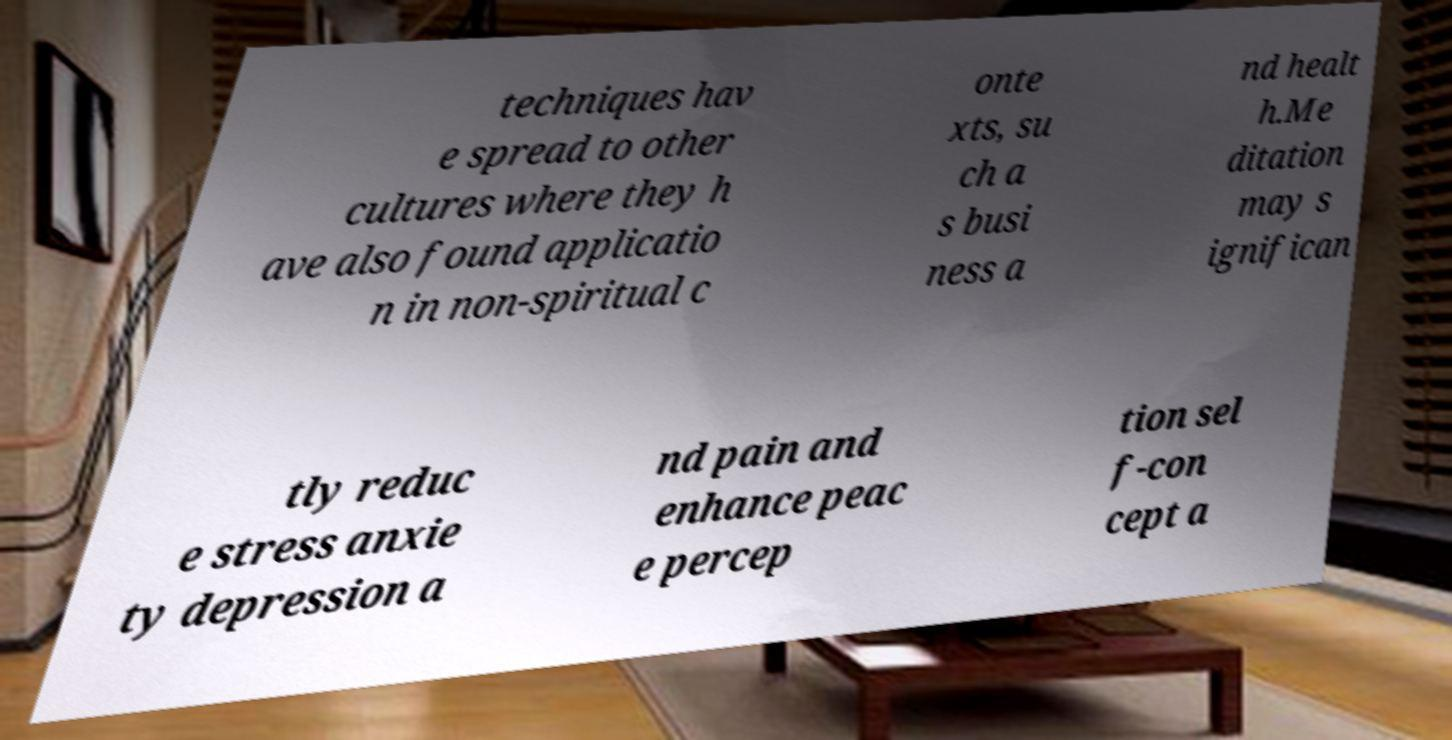What messages or text are displayed in this image? I need them in a readable, typed format. techniques hav e spread to other cultures where they h ave also found applicatio n in non-spiritual c onte xts, su ch a s busi ness a nd healt h.Me ditation may s ignifican tly reduc e stress anxie ty depression a nd pain and enhance peac e percep tion sel f-con cept a 